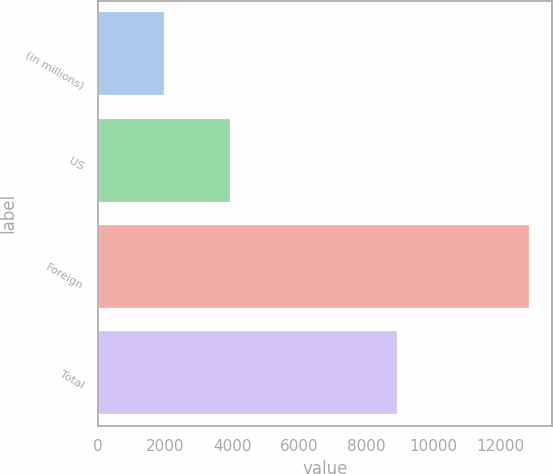Convert chart. <chart><loc_0><loc_0><loc_500><loc_500><bar_chart><fcel>(in millions)<fcel>US<fcel>Foreign<fcel>Total<nl><fcel>2007<fcel>3957<fcel>12900<fcel>8943<nl></chart> 